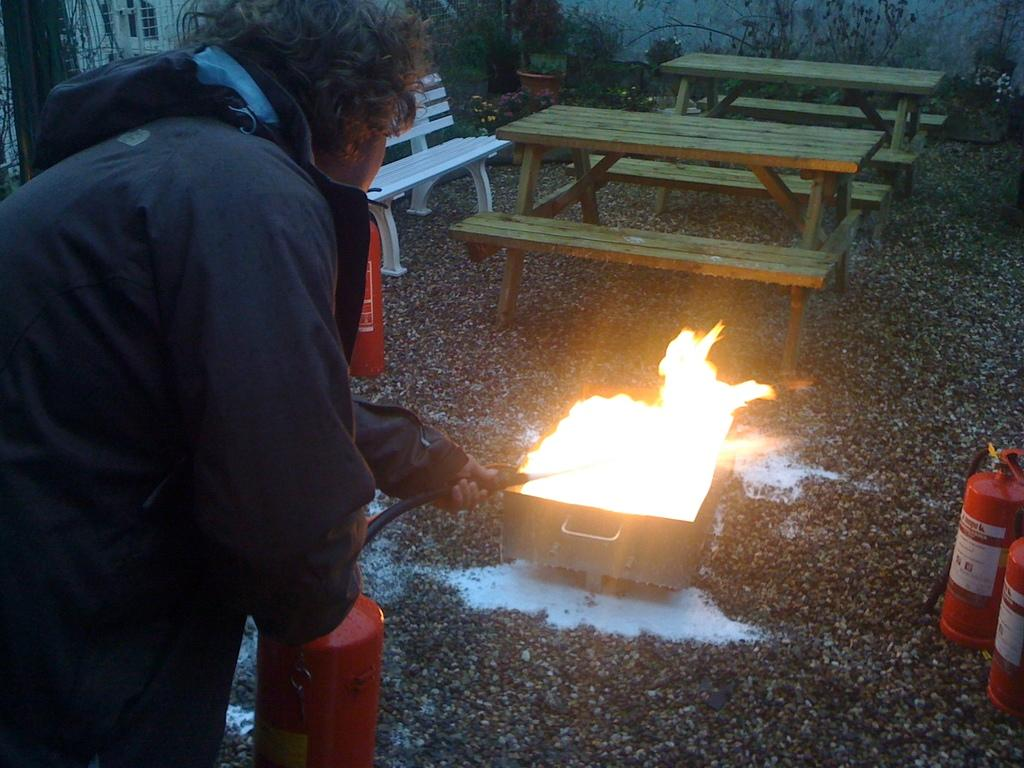What is the person in the image doing? The person is standing in the image and holding a fire extinguisher pipe. What can be seen in the background of the image? There are flower plants and a window visible in the background. What type of creature can be seen folding its wings in the image? There is no creature present in the image, and therefore no folding of wings can be observed. 